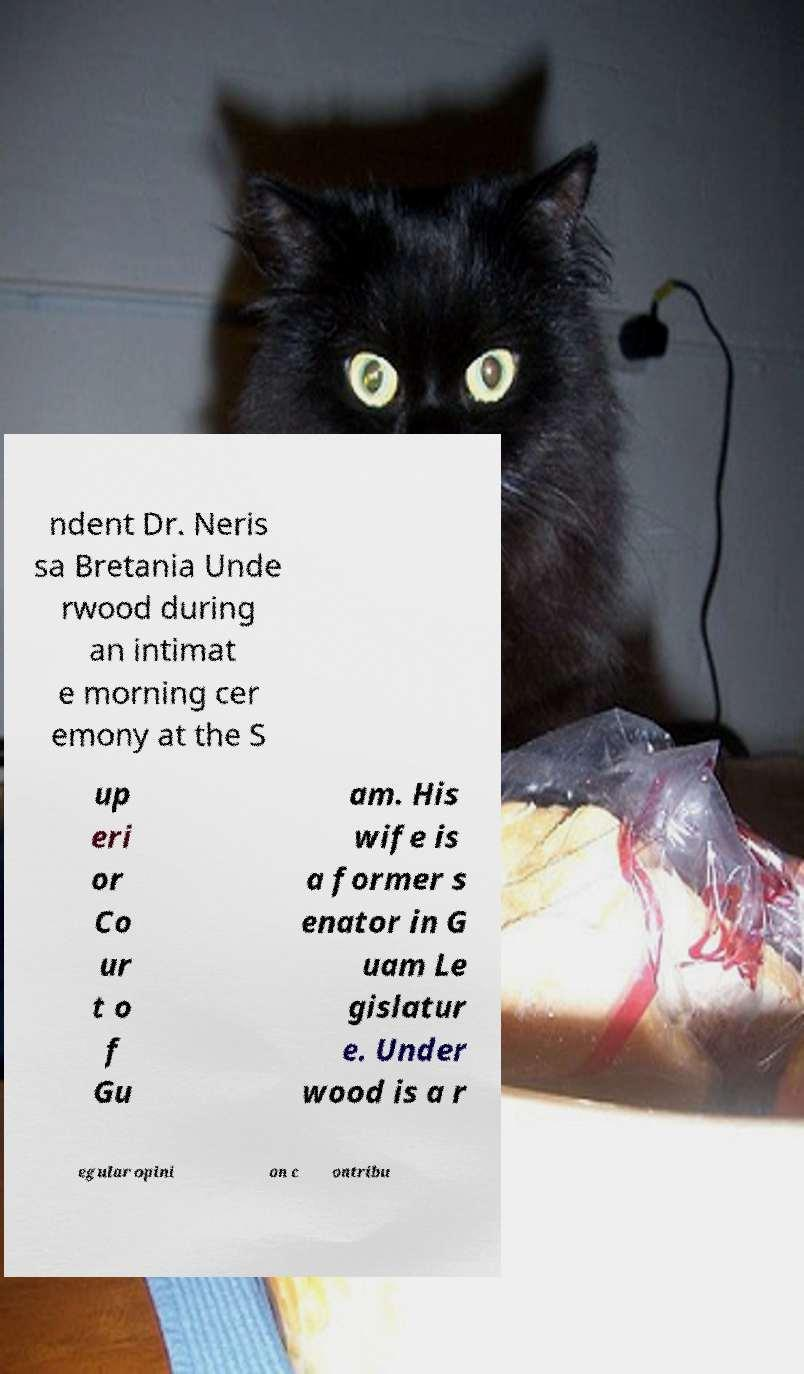I need the written content from this picture converted into text. Can you do that? ndent Dr. Neris sa Bretania Unde rwood during an intimat e morning cer emony at the S up eri or Co ur t o f Gu am. His wife is a former s enator in G uam Le gislatur e. Under wood is a r egular opini on c ontribu 